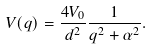<formula> <loc_0><loc_0><loc_500><loc_500>V ( q ) = \frac { 4 V _ { 0 } } { d ^ { 2 } } \frac { 1 } { q ^ { 2 } + \alpha ^ { 2 } } .</formula> 